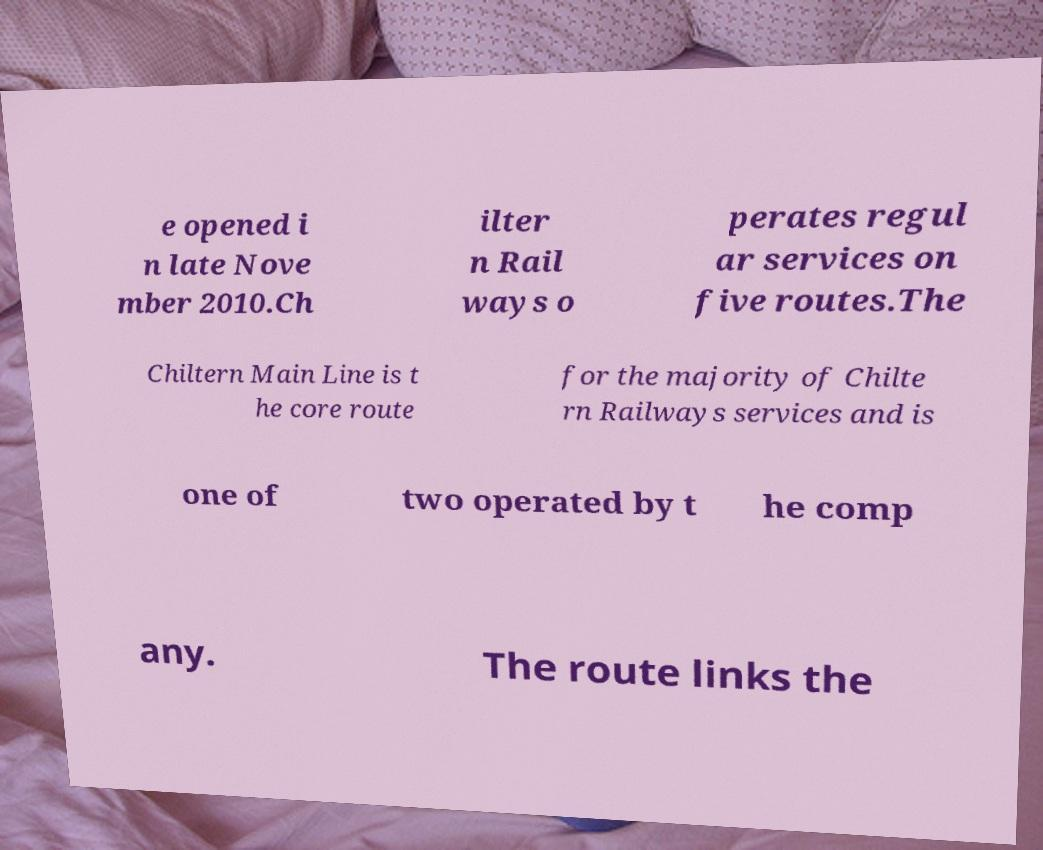Could you extract and type out the text from this image? e opened i n late Nove mber 2010.Ch ilter n Rail ways o perates regul ar services on five routes.The Chiltern Main Line is t he core route for the majority of Chilte rn Railways services and is one of two operated by t he comp any. The route links the 